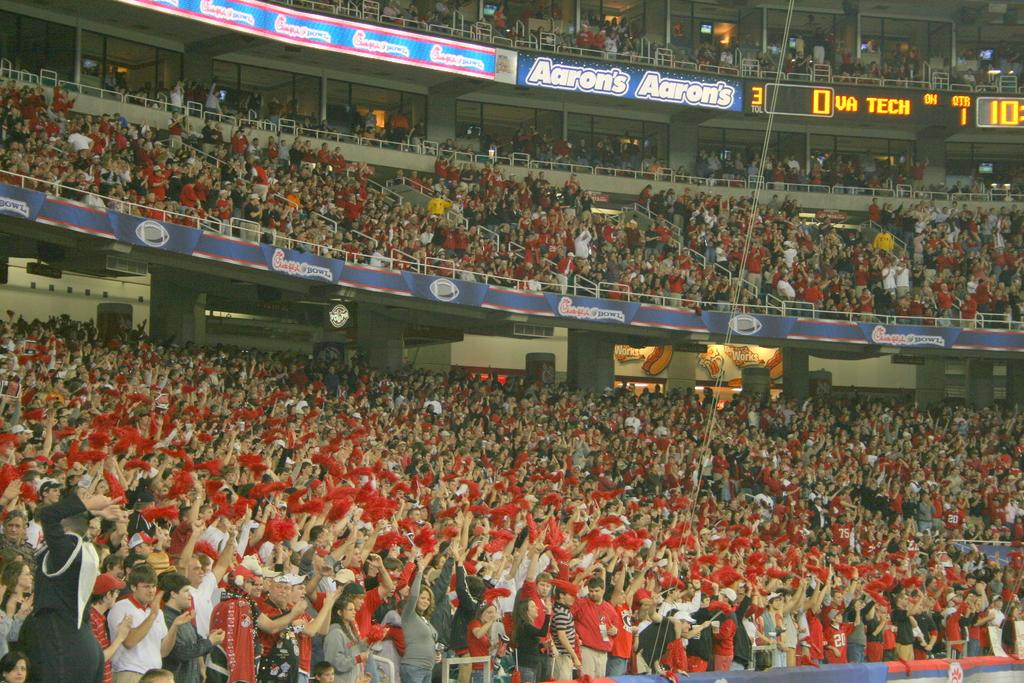What is the main subject of the image? The main subject of the image is a large audience. What are the audience members holding in their hands? The audience members are holding red cloths. Are there any other visible elements in the image besides the audience? Yes, there are banners and screens present in the image. What type of loaf is being served to the audience in the image? There is no loaf present in the image; the audience members are holding red cloths. Can you see a crown on any of the audience members in the image? There is no crown visible on any of the audience members in the image. 